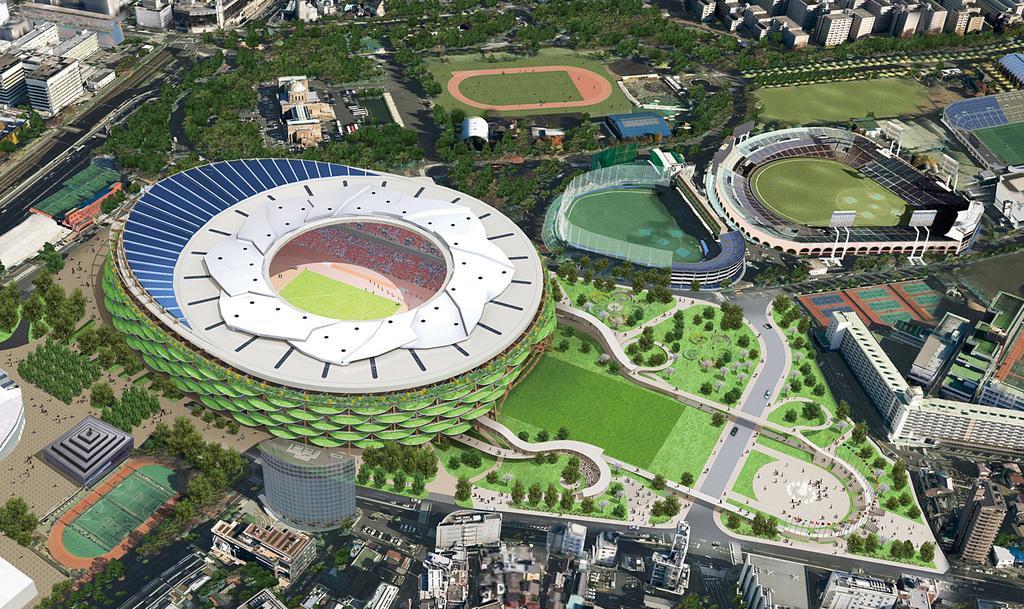Could you give a brief overview of what you see in this image? In the picture we can see an Ariel view of the city, in that we can see at stadiums, gardens, plants, trees and buildings and we can also see a road and some vehicles on it. 